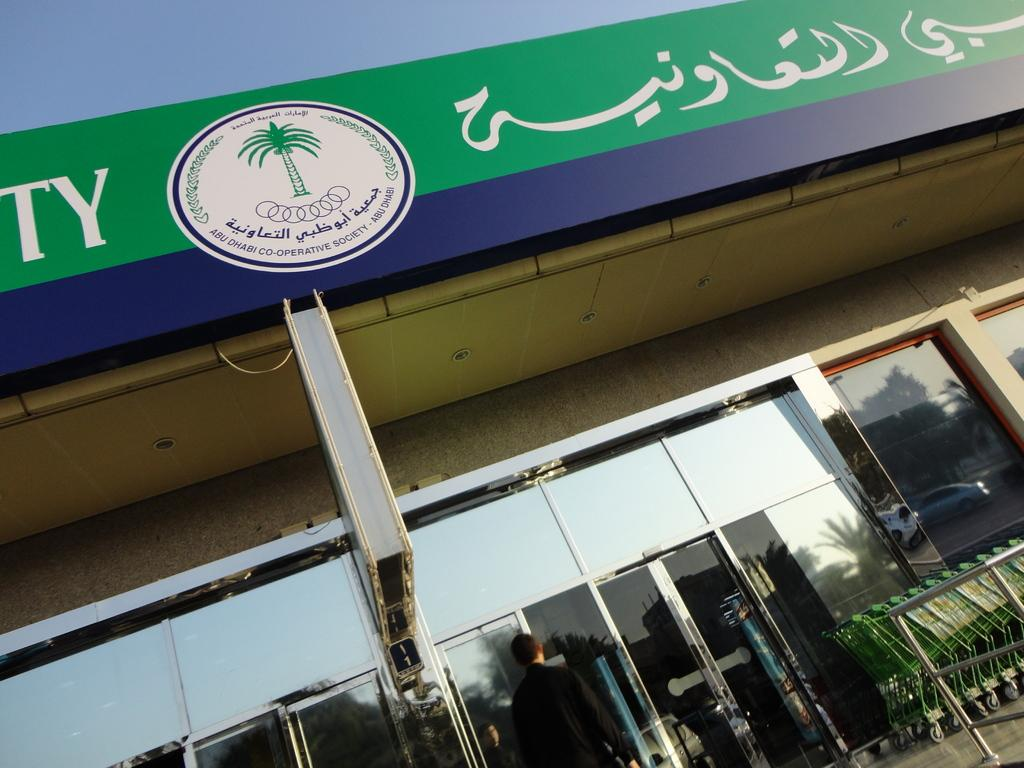What is the main structure in the image? There is a building with a logo in the image. What can be seen on the building besides the logo? There is text on the building. Who or what else is present in the image? There is a person and vehicles in the image. What type of natural elements can be seen in the image? There are trees in the image. Can you describe any other objects present in the image? There are other objects in the image, but their specific details are not mentioned in the provided facts. What type of toothpaste is the person using in the image? There is no toothpaste present in the image, and the person's actions are not described. 